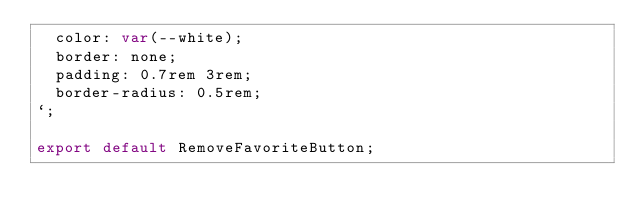<code> <loc_0><loc_0><loc_500><loc_500><_TypeScript_>  color: var(--white);
  border: none;
  padding: 0.7rem 3rem;
  border-radius: 0.5rem;
`;

export default RemoveFavoriteButton;
</code> 